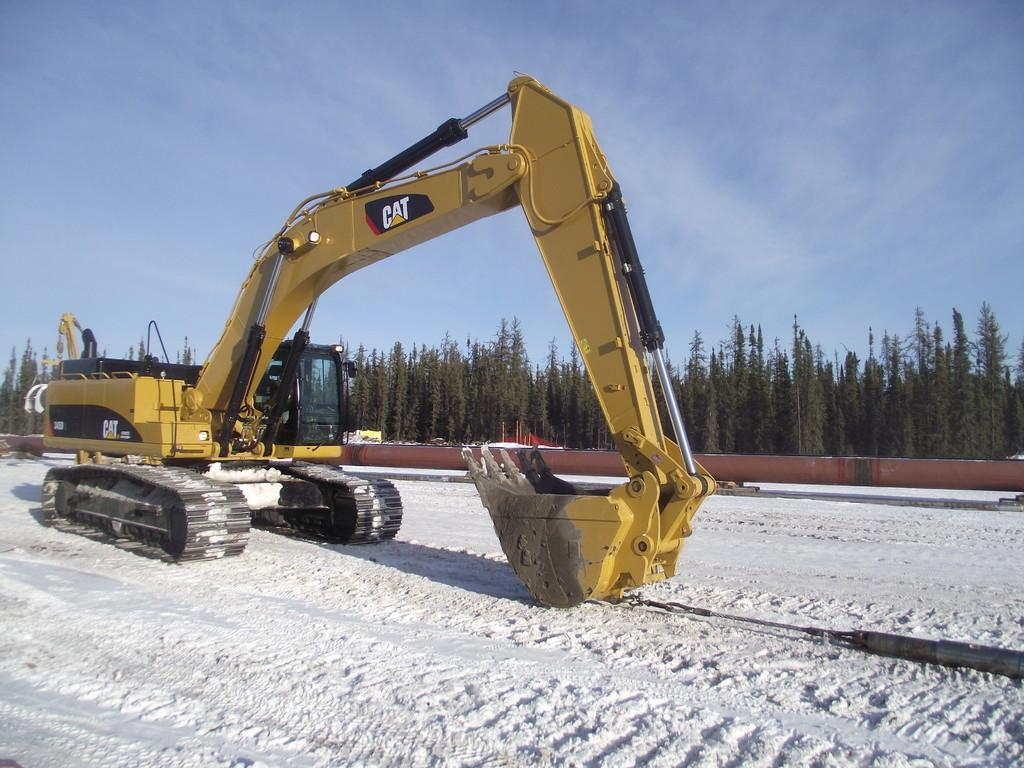What is the predominant weather condition in the image? There is snow in the image, indicating a cold and wintry condition. What type of machinery is present in the image? There is an excavator in the image. What can be seen in the distance in the image? There are trees in the background of the image. What else is visible in the background of the image? The sky is visible in the background of the image. Can you see a river flowing through the snow in the image? There is no river visible in the image; it only shows snow, an excavator, trees, and the sky. What type of yam is being used to dig through the snow in the image? There is no yam present in the image; it features an excavator, snow, trees, and the sky. 